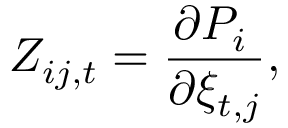Convert formula to latex. <formula><loc_0><loc_0><loc_500><loc_500>Z _ { i j , t } = \frac { \partial P _ { i } \, } { \partial \xi _ { t , j } } ,</formula> 